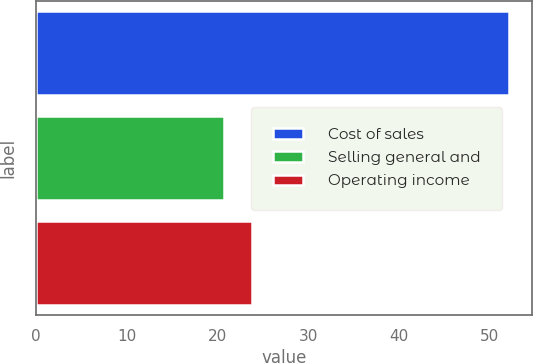<chart> <loc_0><loc_0><loc_500><loc_500><bar_chart><fcel>Cost of sales<fcel>Selling general and<fcel>Operating income<nl><fcel>52.1<fcel>20.7<fcel>23.84<nl></chart> 